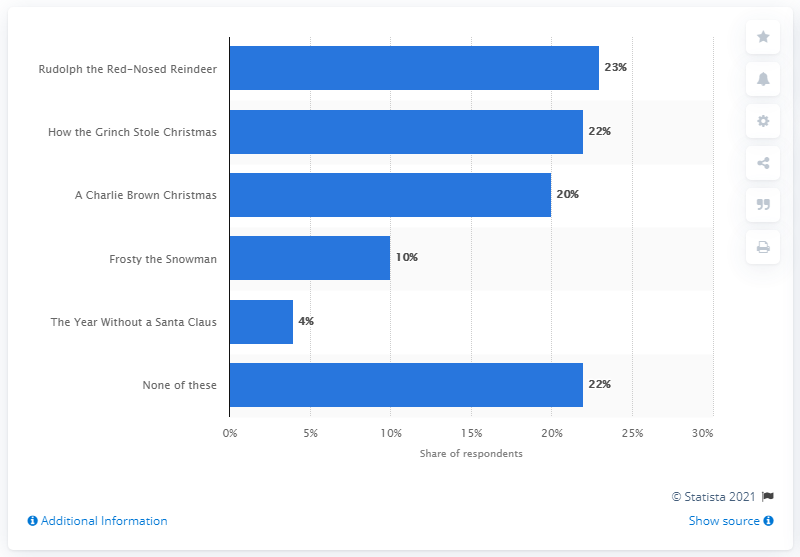List a handful of essential elements in this visual. In the year 2009, the most beloved animated holiday television special was 'Rudolph the Red-Nosed Reindeer.' 